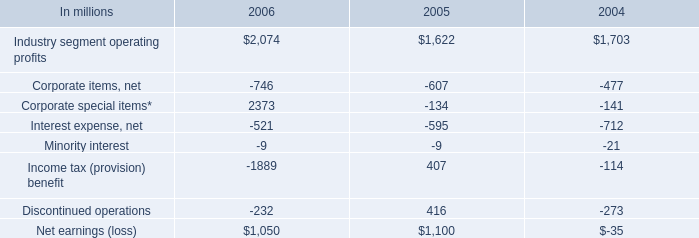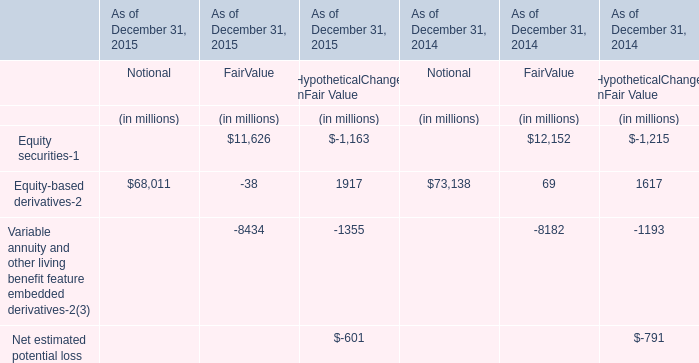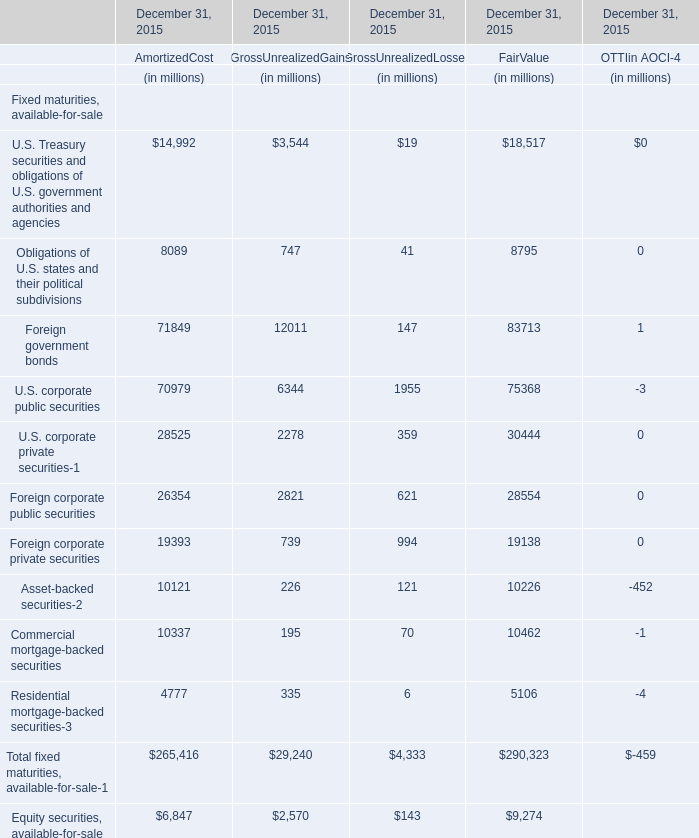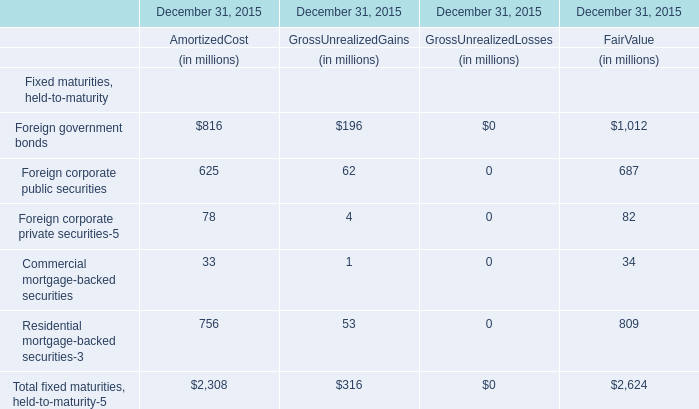What is the sum of the U.S. corporate private securities-1 of Fixed maturities, available-for-sale in the years where Foreign government bonds of Fixed maturities, available-for-sale is positive? (in million) 
Computations: (((28525 + 2278) + 359) + 30444)
Answer: 61606.0. 